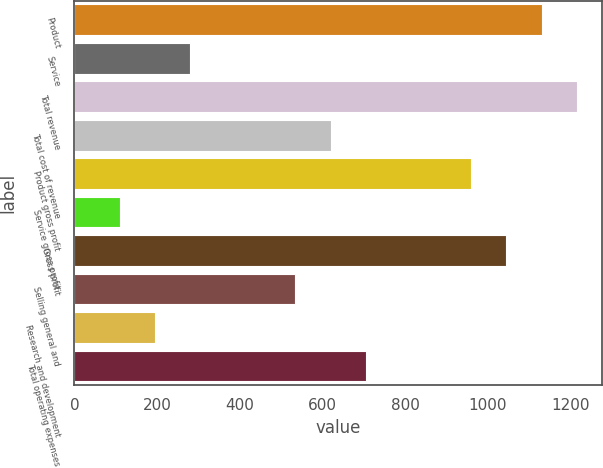Convert chart to OTSL. <chart><loc_0><loc_0><loc_500><loc_500><bar_chart><fcel>Product<fcel>Service<fcel>Total revenue<fcel>Total cost of revenue<fcel>Product gross profit<fcel>Service gross profit<fcel>Gross profit<fcel>Selling general and<fcel>Research and development<fcel>Total operating expenses<nl><fcel>1130.05<fcel>279.55<fcel>1215.1<fcel>619.75<fcel>959.95<fcel>109.45<fcel>1045<fcel>534.7<fcel>194.5<fcel>704.8<nl></chart> 